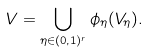Convert formula to latex. <formula><loc_0><loc_0><loc_500><loc_500>V = \bigcup _ { \eta \in ( 0 , 1 ) ^ { r } } \phi _ { \eta } ( V _ { \eta } ) .</formula> 